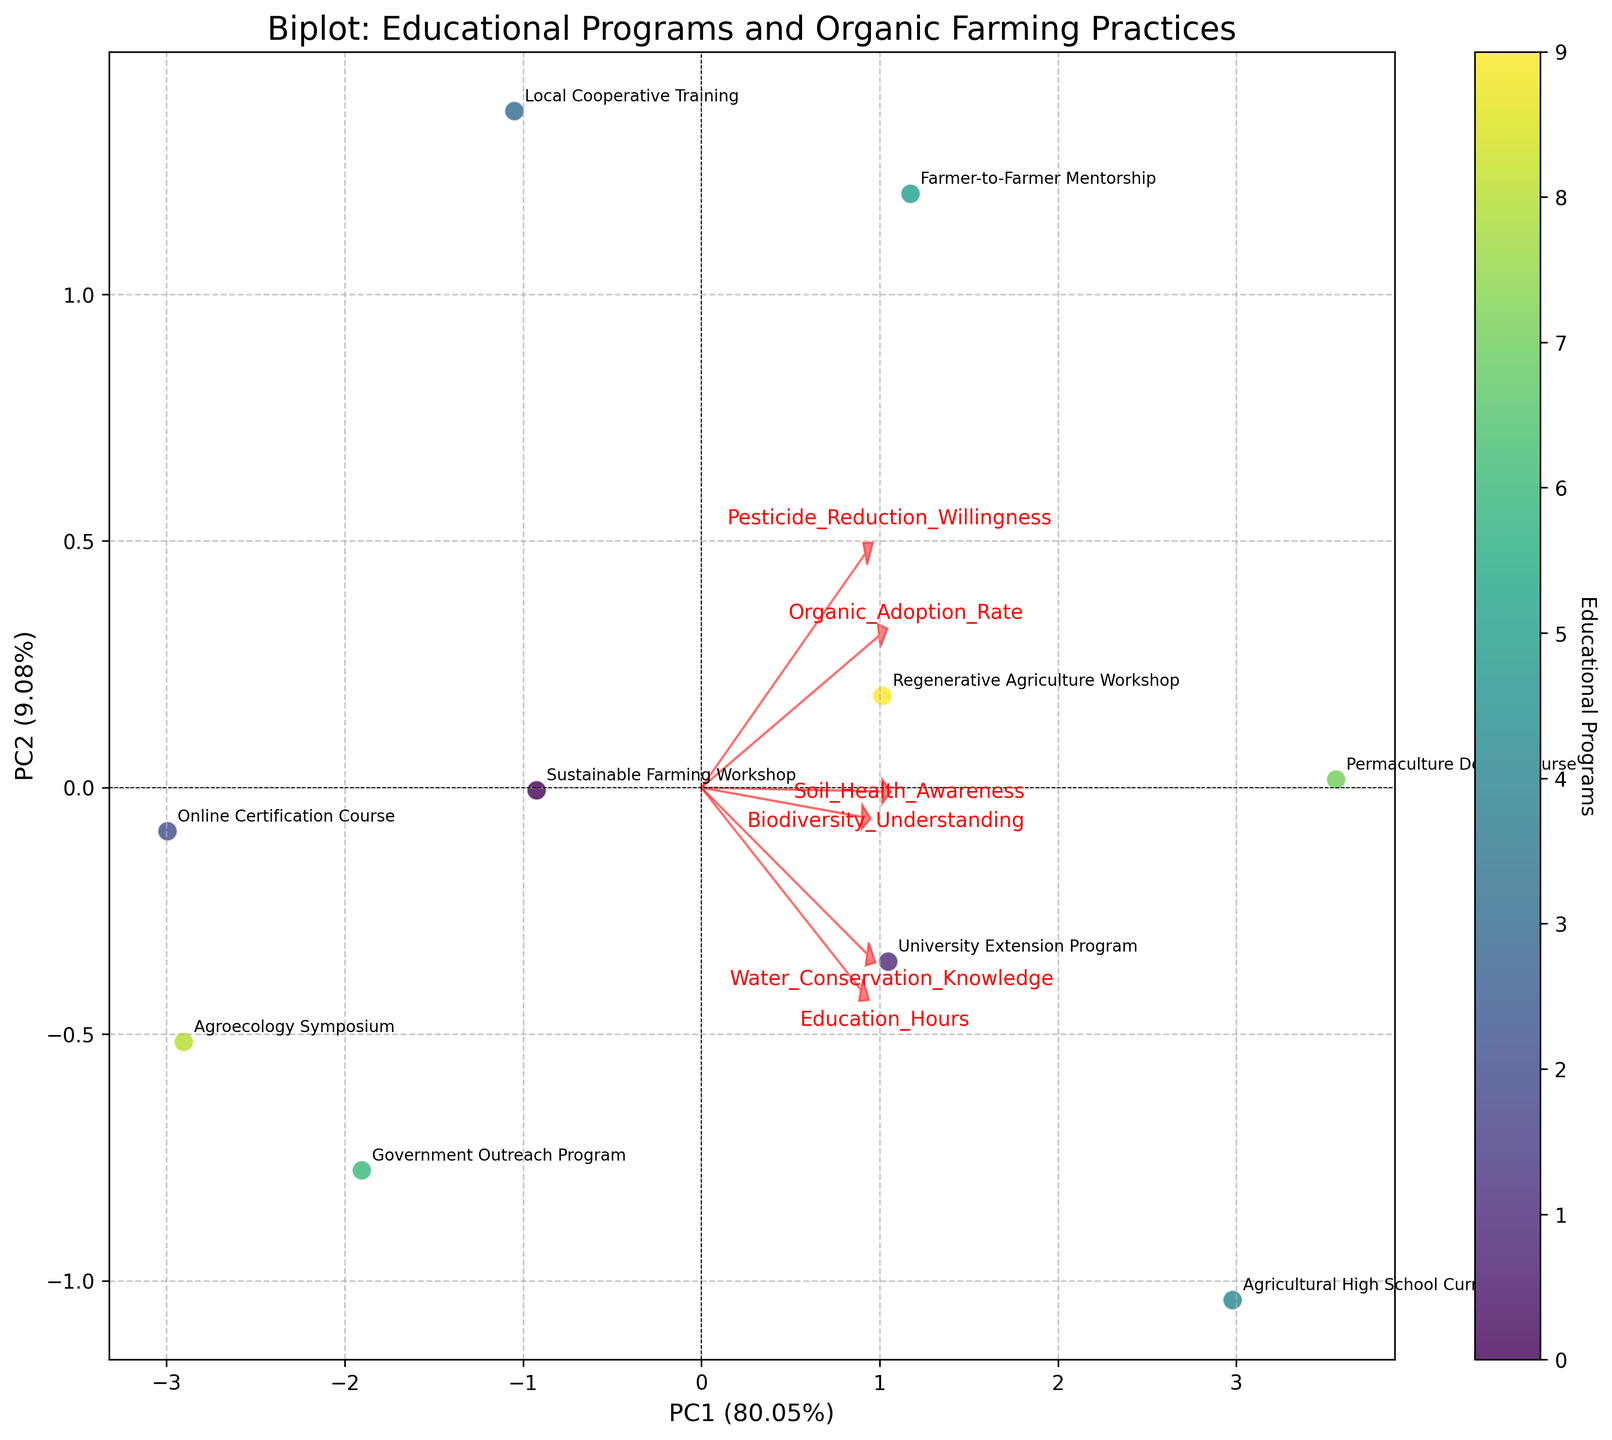Which educational program has the highest adoption rate of organic farming practices? The data points representing the educational programs are annotated in the plot. By examining the y-axis, we can see that the Permaculture Design Course has the highest adoption rate of organic farming practices.
Answer: Permaculture Design Course What percentage of the variance is explained by PC1? The axis label for PC1 indicates the variance it explains. The label on the x-axis shows that PC1 accounts for 48.7% of the variance.
Answer: 48.7% Which two educational programs are closest to each other in the biplot? By examining the proximity of the data points, the Sustainable Farming Workshop and Regenerative Agriculture Workshop appear to be the closest to each other in the biplot.
Answer: Sustainable Farming Workshop and Regenerative Agriculture Workshop How is Soil Health Awareness represented in the biplot? Arrows indicate the relationship of individual variables. The direction and length of the arrow for Soil Health Awareness show how it correlates with the principal components.
Answer: By an arrow What is the primary educational focus of the Farmer-to-Farmer Mentorship according to the biplot? The position of the Farmer-to-Farmer Mentorship data point and the direction of the arrows for various educational outcomes help us identify its primary focus. It is closely associated with Pesticide Reduction Willingness.
Answer: Pesticide Reduction Willingness Which educational program has the lowest PC1 score? The x-axis represents PC1 scores. By examining the data points, Agroecology Symposium has the lowest PC1 score.
Answer: Agroecology Symposium Which two features are most strongly correlated with each other? The direction and closeness of the arrows in the biplot suggest that overlapping or very similar vectors imply strong correlation. Biodiversity Understanding and Permaculture Design Course seem to be most closely aligned.
Answer: Biodiversity Understanding and Permaculture Design Course How does the length of the arrows help in interpreting the biplot? Longer arrows represent stronger contributions of the respective features to the principal components, indicating higher importance and variance contribution.
Answer: Indicates strong contributions 